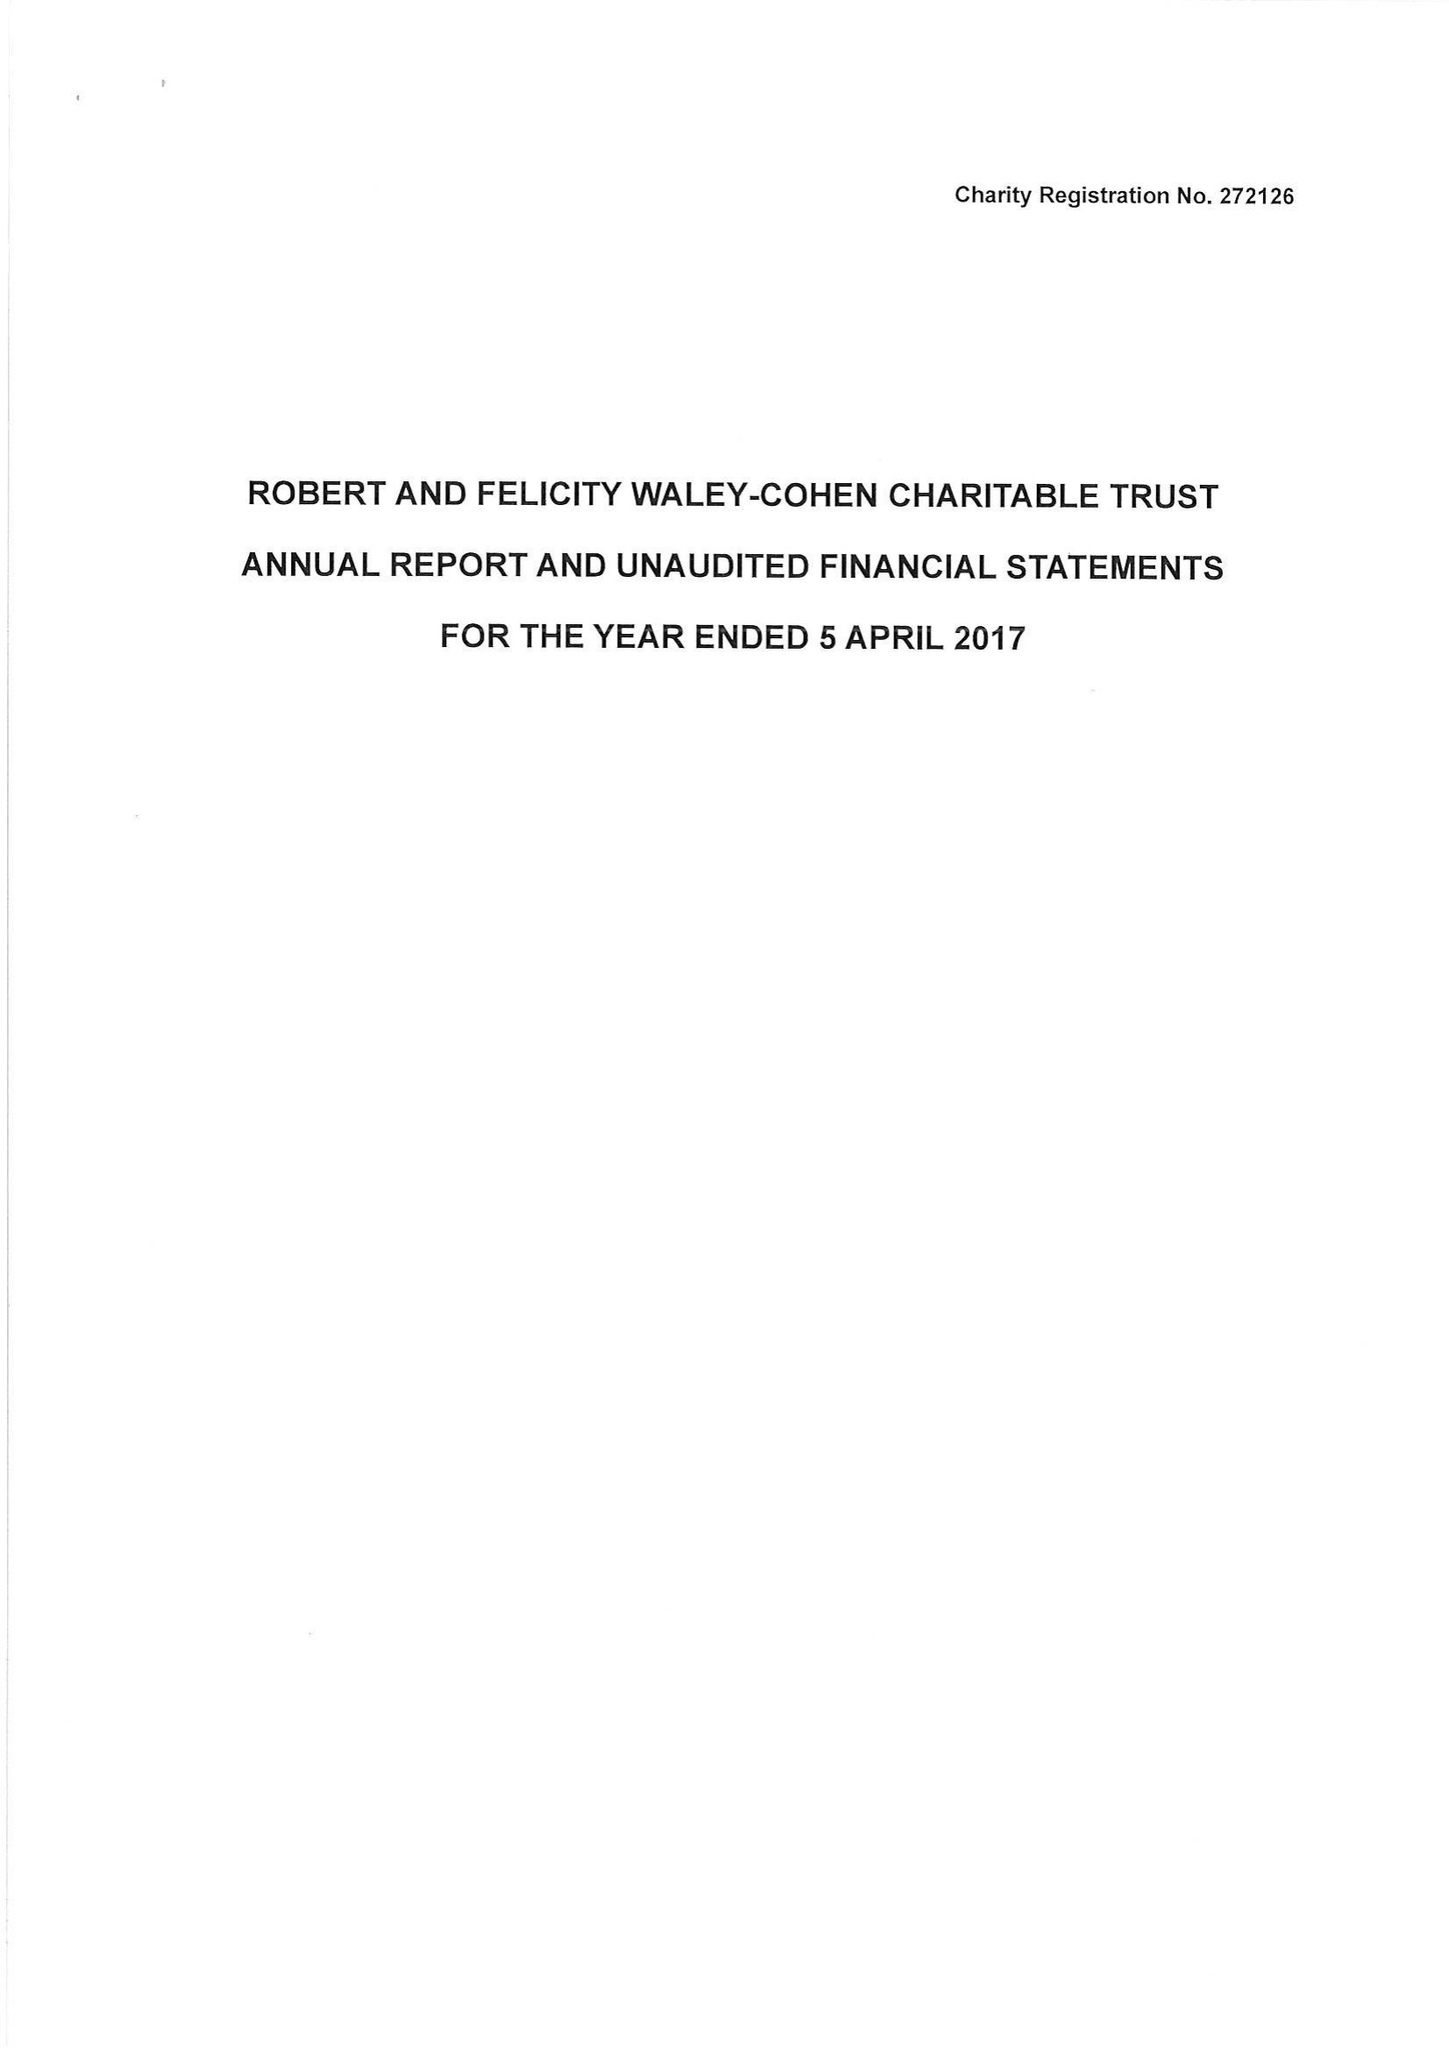What is the value for the address__postcode?
Answer the question using a single word or phrase. SW7 2TB 